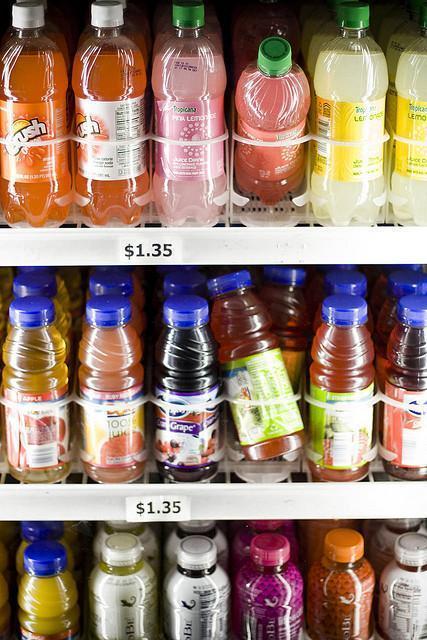How many refrigerators are there?
Give a very brief answer. 1. How many bottles are there?
Give a very brief answer. 14. How many people are standing?
Give a very brief answer. 0. 